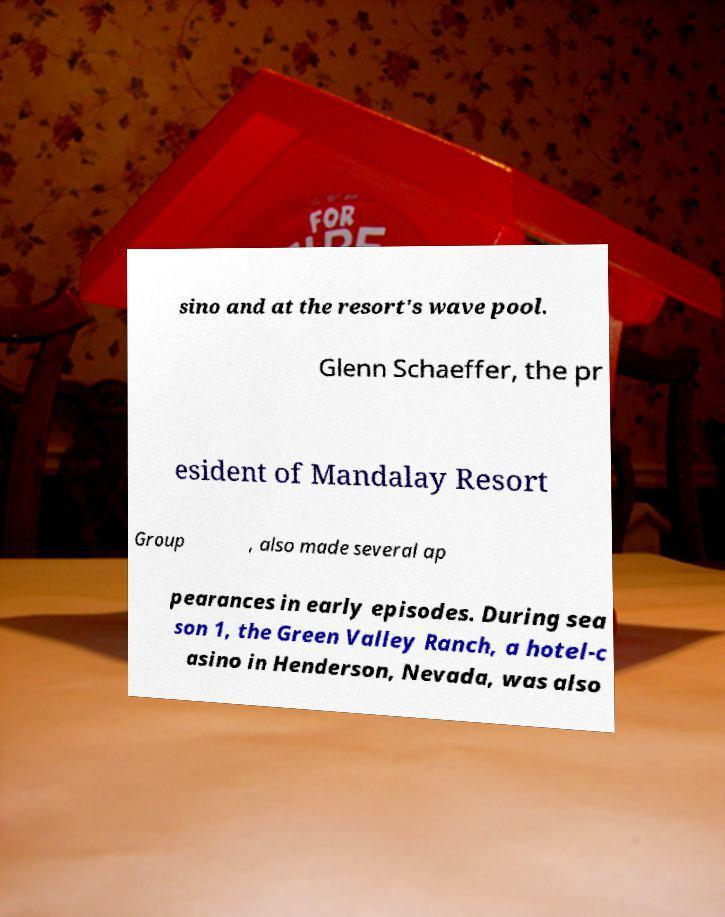Please read and relay the text visible in this image. What does it say? sino and at the resort's wave pool. Glenn Schaeffer, the pr esident of Mandalay Resort Group , also made several ap pearances in early episodes. During sea son 1, the Green Valley Ranch, a hotel-c asino in Henderson, Nevada, was also 